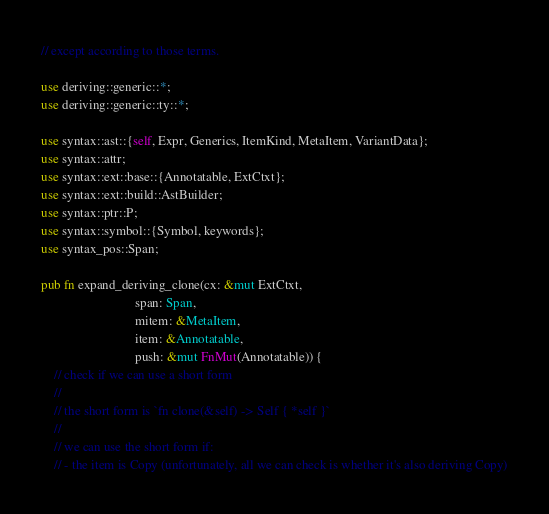<code> <loc_0><loc_0><loc_500><loc_500><_Rust_>// except according to those terms.

use deriving::generic::*;
use deriving::generic::ty::*;

use syntax::ast::{self, Expr, Generics, ItemKind, MetaItem, VariantData};
use syntax::attr;
use syntax::ext::base::{Annotatable, ExtCtxt};
use syntax::ext::build::AstBuilder;
use syntax::ptr::P;
use syntax::symbol::{Symbol, keywords};
use syntax_pos::Span;

pub fn expand_deriving_clone(cx: &mut ExtCtxt,
                             span: Span,
                             mitem: &MetaItem,
                             item: &Annotatable,
                             push: &mut FnMut(Annotatable)) {
    // check if we can use a short form
    //
    // the short form is `fn clone(&self) -> Self { *self }`
    //
    // we can use the short form if:
    // - the item is Copy (unfortunately, all we can check is whether it's also deriving Copy)</code> 